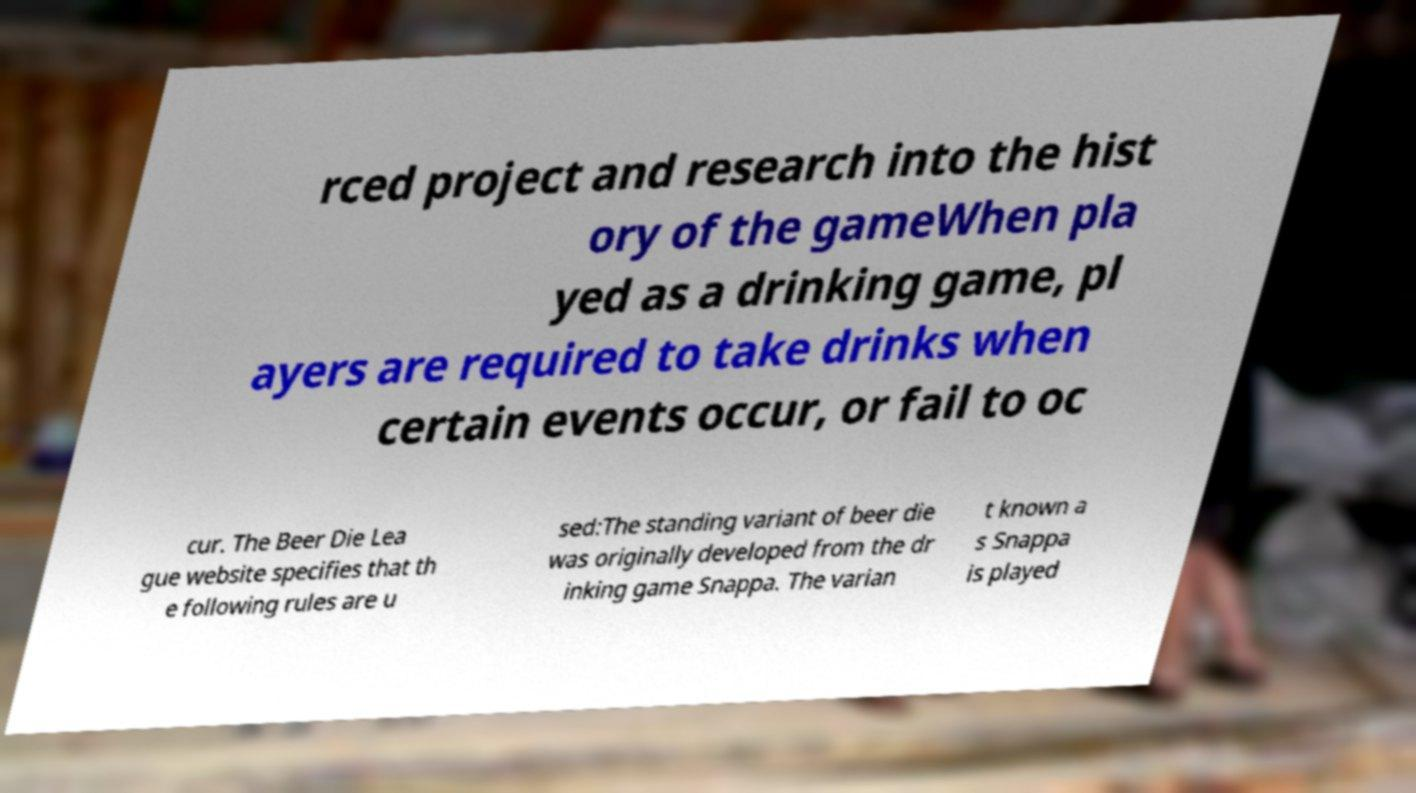Could you extract and type out the text from this image? rced project and research into the hist ory of the gameWhen pla yed as a drinking game, pl ayers are required to take drinks when certain events occur, or fail to oc cur. The Beer Die Lea gue website specifies that th e following rules are u sed:The standing variant of beer die was originally developed from the dr inking game Snappa. The varian t known a s Snappa is played 